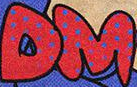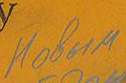What text is displayed in these images sequentially, separated by a semicolon? DM; Hobum 